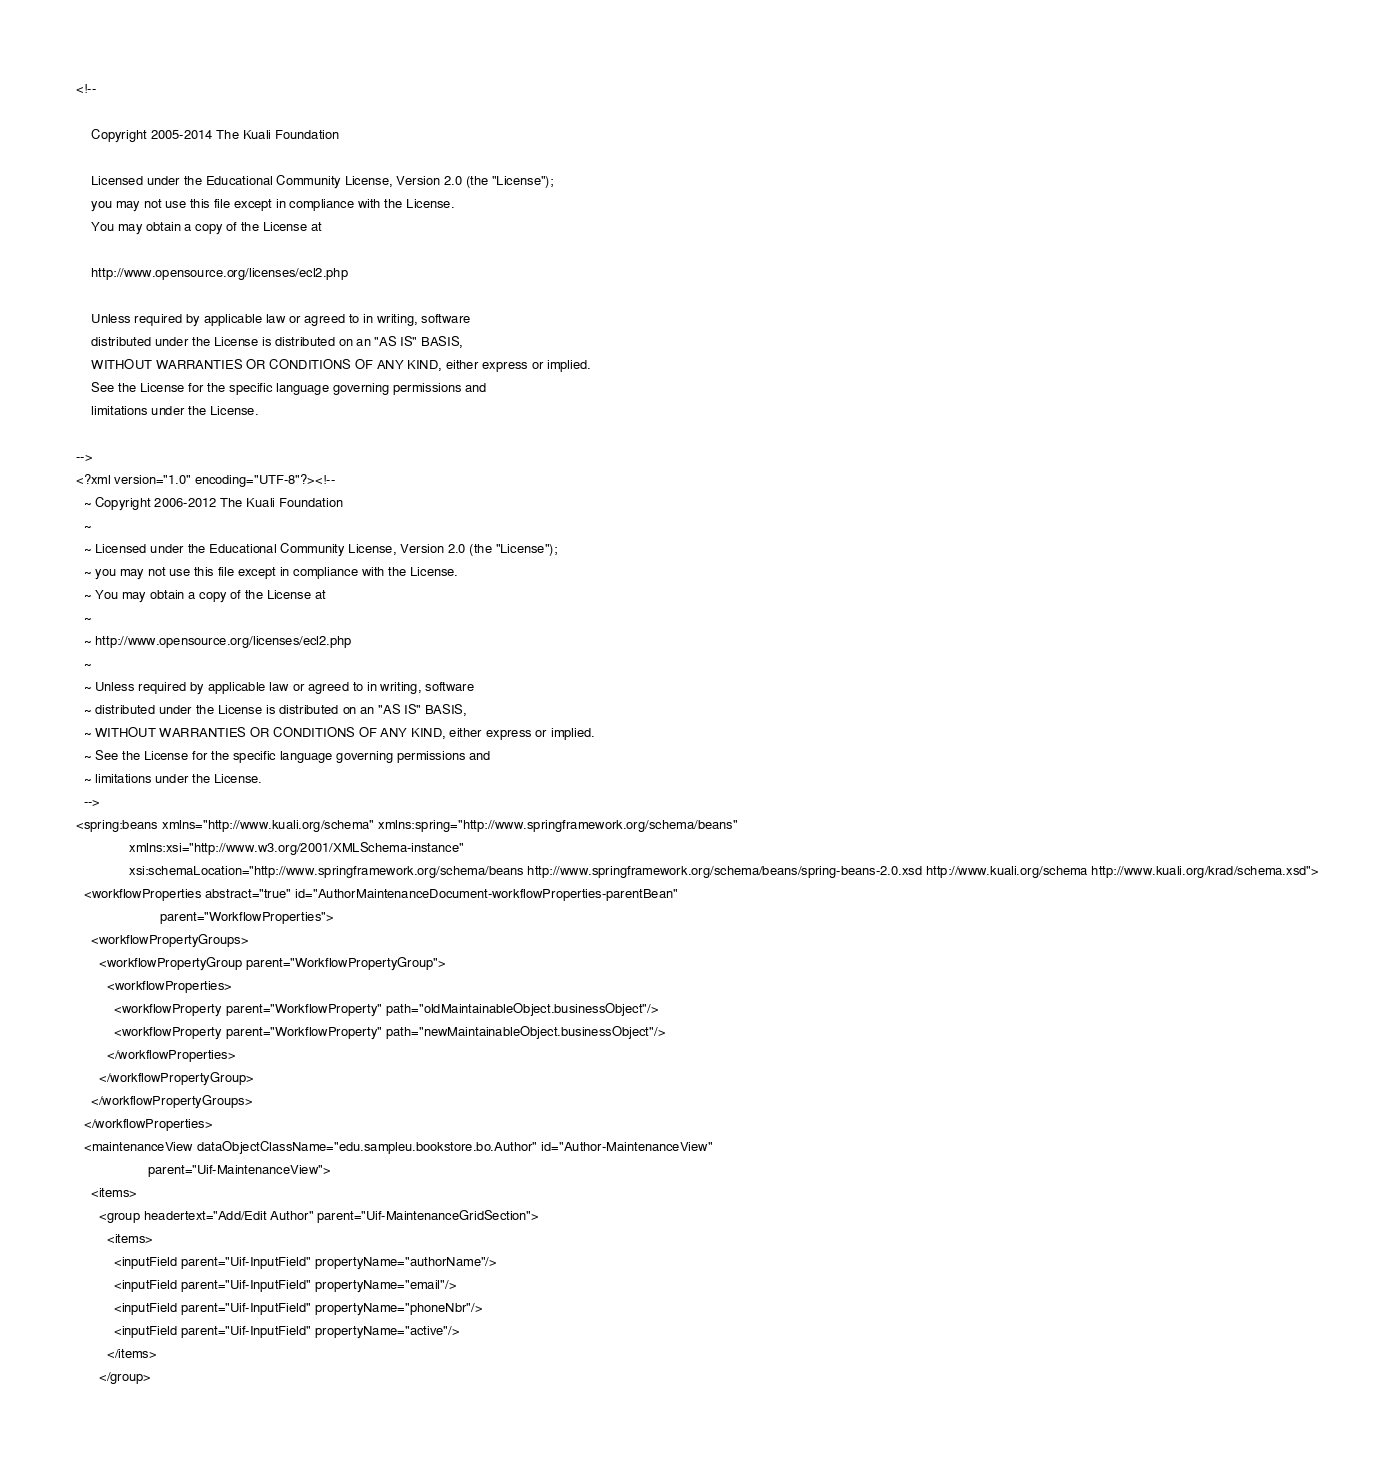Convert code to text. <code><loc_0><loc_0><loc_500><loc_500><_XML_><!--

    Copyright 2005-2014 The Kuali Foundation

    Licensed under the Educational Community License, Version 2.0 (the "License");
    you may not use this file except in compliance with the License.
    You may obtain a copy of the License at

    http://www.opensource.org/licenses/ecl2.php

    Unless required by applicable law or agreed to in writing, software
    distributed under the License is distributed on an "AS IS" BASIS,
    WITHOUT WARRANTIES OR CONDITIONS OF ANY KIND, either express or implied.
    See the License for the specific language governing permissions and
    limitations under the License.

-->
<?xml version="1.0" encoding="UTF-8"?><!--
  ~ Copyright 2006-2012 The Kuali Foundation
  ~
  ~ Licensed under the Educational Community License, Version 2.0 (the "License");
  ~ you may not use this file except in compliance with the License.
  ~ You may obtain a copy of the License at
  ~
  ~ http://www.opensource.org/licenses/ecl2.php
  ~
  ~ Unless required by applicable law or agreed to in writing, software
  ~ distributed under the License is distributed on an "AS IS" BASIS,
  ~ WITHOUT WARRANTIES OR CONDITIONS OF ANY KIND, either express or implied.
  ~ See the License for the specific language governing permissions and
  ~ limitations under the License.
  -->
<spring:beans xmlns="http://www.kuali.org/schema" xmlns:spring="http://www.springframework.org/schema/beans"
              xmlns:xsi="http://www.w3.org/2001/XMLSchema-instance"
              xsi:schemaLocation="http://www.springframework.org/schema/beans http://www.springframework.org/schema/beans/spring-beans-2.0.xsd http://www.kuali.org/schema http://www.kuali.org/krad/schema.xsd">
  <workflowProperties abstract="true" id="AuthorMaintenanceDocument-workflowProperties-parentBean"
                      parent="WorkflowProperties">
    <workflowPropertyGroups>
      <workflowPropertyGroup parent="WorkflowPropertyGroup">
        <workflowProperties>
          <workflowProperty parent="WorkflowProperty" path="oldMaintainableObject.businessObject"/>
          <workflowProperty parent="WorkflowProperty" path="newMaintainableObject.businessObject"/>
        </workflowProperties>
      </workflowPropertyGroup>
    </workflowPropertyGroups>
  </workflowProperties>
  <maintenanceView dataObjectClassName="edu.sampleu.bookstore.bo.Author" id="Author-MaintenanceView"
                   parent="Uif-MaintenanceView">
    <items>
      <group headertext="Add/Edit Author" parent="Uif-MaintenanceGridSection">
        <items>
          <inputField parent="Uif-InputField" propertyName="authorName"/>
          <inputField parent="Uif-InputField" propertyName="email"/>
          <inputField parent="Uif-InputField" propertyName="phoneNbr"/>
          <inputField parent="Uif-InputField" propertyName="active"/>
        </items>
      </group></code> 